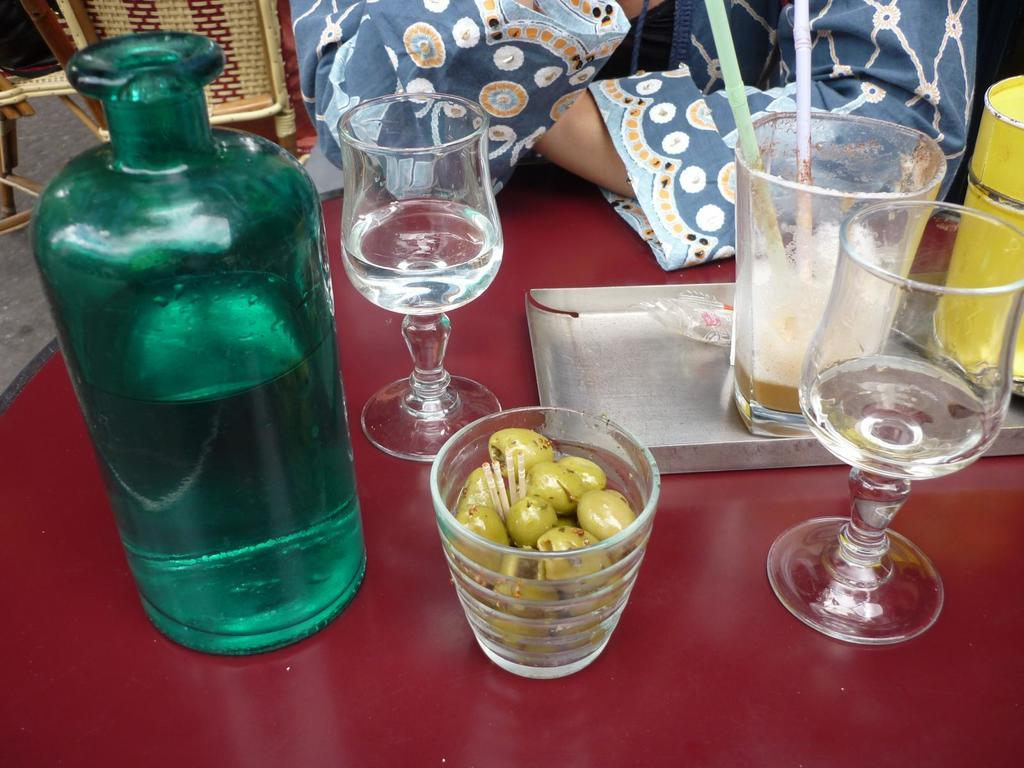What type of container is present in the image? There is a bottle in the image. What type of glassware is present in the image? There is a wine glass and a juice glass in a tray in the image. What type of heart-shaped object can be seen in the image? There is no heart-shaped object present in the image. 